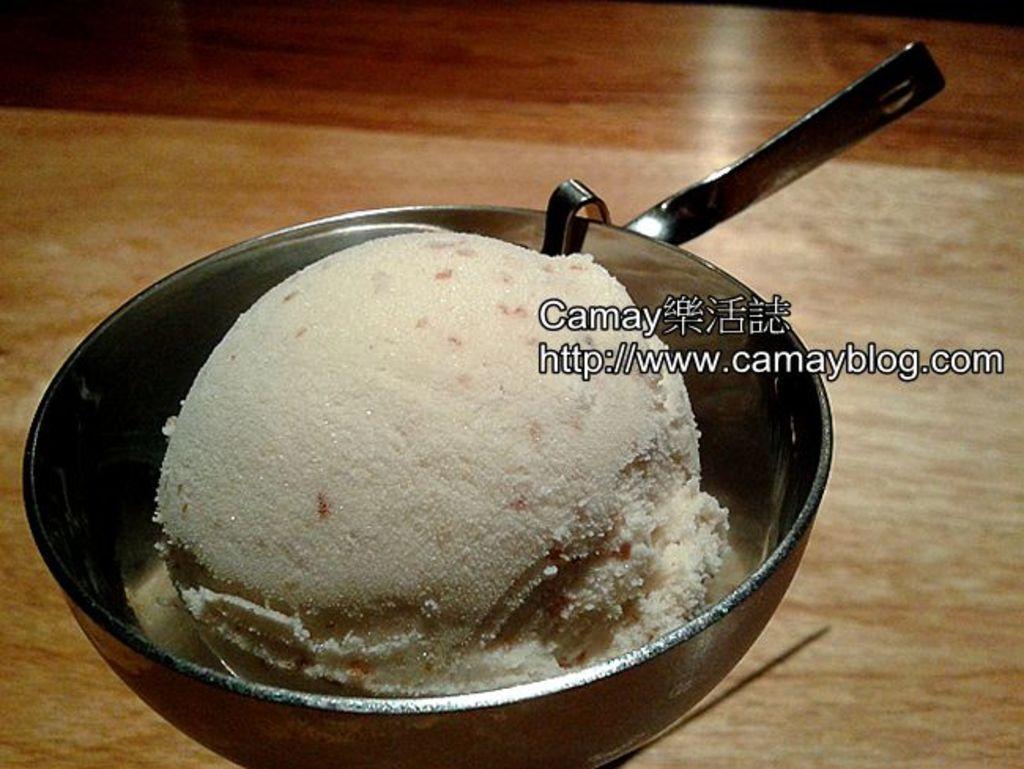In one or two sentences, can you explain what this image depicts? In this picture there is an edible placed in a bowl and there is something written beside it. 